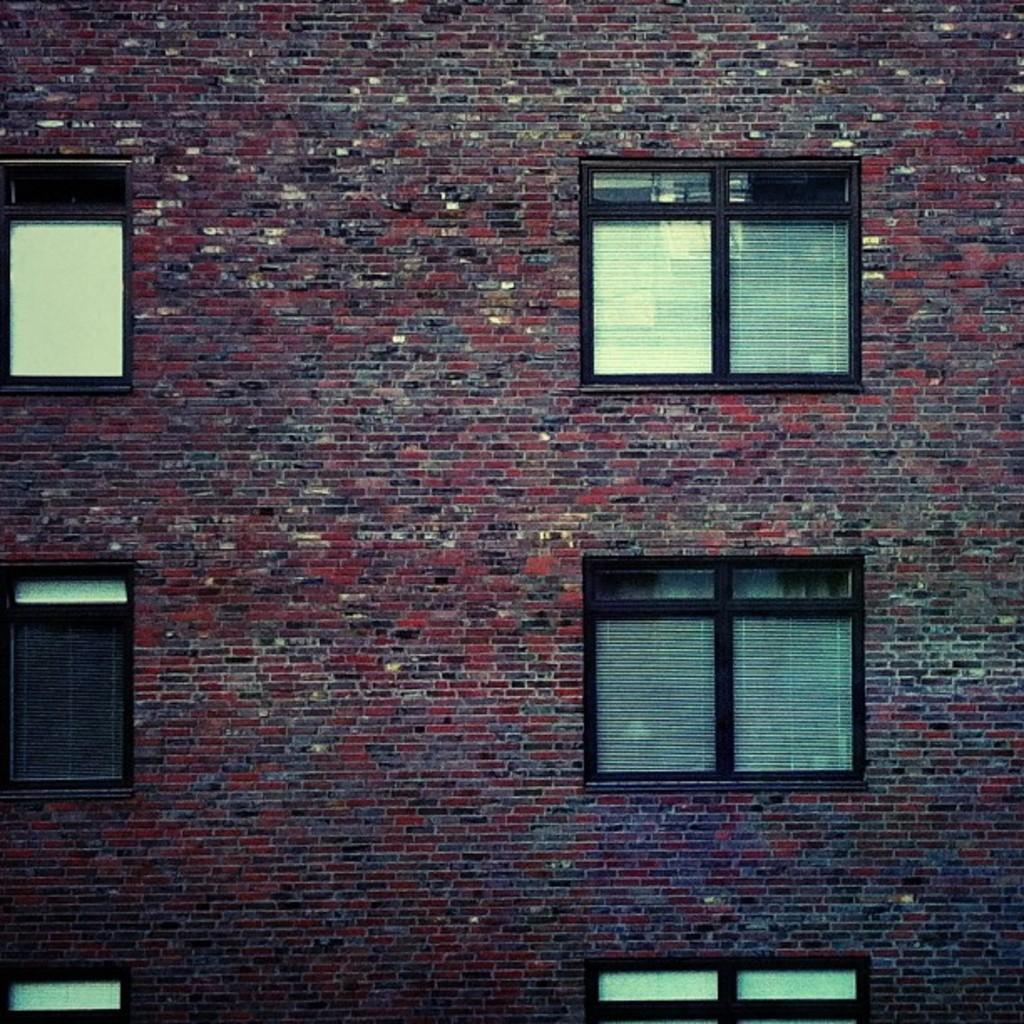Can you describe this image briefly? In the image in the center, we can see one building, brick wall and windows. 